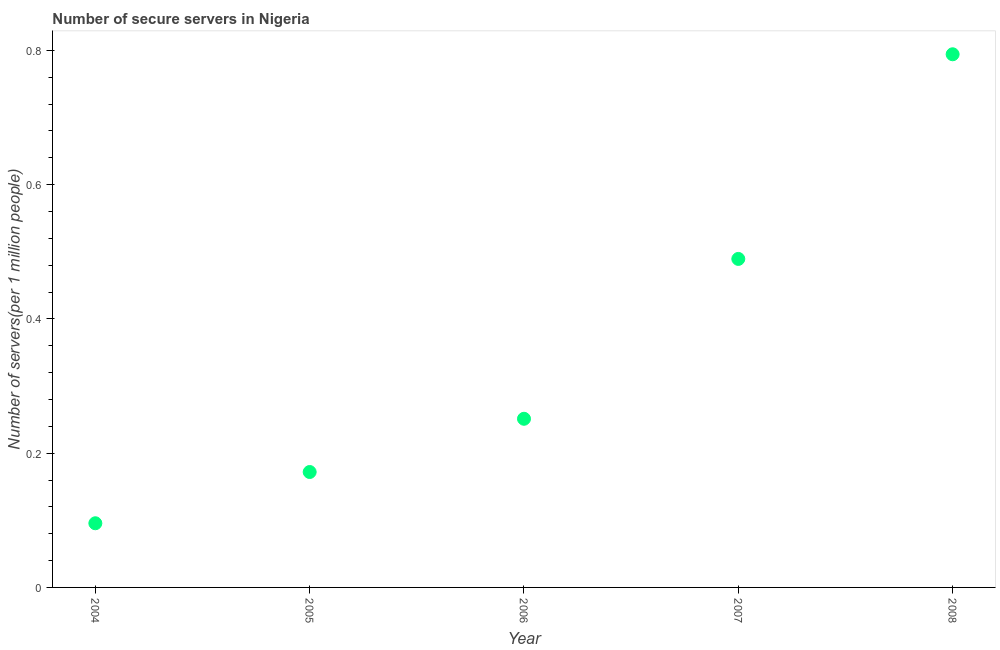What is the number of secure internet servers in 2004?
Provide a succinct answer. 0.1. Across all years, what is the maximum number of secure internet servers?
Keep it short and to the point. 0.79. Across all years, what is the minimum number of secure internet servers?
Offer a very short reply. 0.1. What is the sum of the number of secure internet servers?
Provide a succinct answer. 1.8. What is the difference between the number of secure internet servers in 2005 and 2007?
Offer a terse response. -0.32. What is the average number of secure internet servers per year?
Provide a succinct answer. 0.36. What is the median number of secure internet servers?
Provide a short and direct response. 0.25. In how many years, is the number of secure internet servers greater than 0.68 ?
Your response must be concise. 1. Do a majority of the years between 2006 and 2008 (inclusive) have number of secure internet servers greater than 0.6000000000000001 ?
Offer a terse response. No. What is the ratio of the number of secure internet servers in 2005 to that in 2008?
Provide a succinct answer. 0.22. Is the number of secure internet servers in 2005 less than that in 2007?
Ensure brevity in your answer.  Yes. What is the difference between the highest and the second highest number of secure internet servers?
Provide a short and direct response. 0.3. Is the sum of the number of secure internet servers in 2005 and 2008 greater than the maximum number of secure internet servers across all years?
Your response must be concise. Yes. What is the difference between the highest and the lowest number of secure internet servers?
Make the answer very short. 0.7. In how many years, is the number of secure internet servers greater than the average number of secure internet servers taken over all years?
Your answer should be compact. 2. How many dotlines are there?
Keep it short and to the point. 1. What is the difference between two consecutive major ticks on the Y-axis?
Provide a short and direct response. 0.2. Are the values on the major ticks of Y-axis written in scientific E-notation?
Your response must be concise. No. Does the graph contain any zero values?
Offer a very short reply. No. Does the graph contain grids?
Provide a short and direct response. No. What is the title of the graph?
Keep it short and to the point. Number of secure servers in Nigeria. What is the label or title of the Y-axis?
Make the answer very short. Number of servers(per 1 million people). What is the Number of servers(per 1 million people) in 2004?
Make the answer very short. 0.1. What is the Number of servers(per 1 million people) in 2005?
Offer a very short reply. 0.17. What is the Number of servers(per 1 million people) in 2006?
Provide a succinct answer. 0.25. What is the Number of servers(per 1 million people) in 2007?
Offer a terse response. 0.49. What is the Number of servers(per 1 million people) in 2008?
Offer a very short reply. 0.79. What is the difference between the Number of servers(per 1 million people) in 2004 and 2005?
Make the answer very short. -0.08. What is the difference between the Number of servers(per 1 million people) in 2004 and 2006?
Your answer should be very brief. -0.16. What is the difference between the Number of servers(per 1 million people) in 2004 and 2007?
Give a very brief answer. -0.39. What is the difference between the Number of servers(per 1 million people) in 2004 and 2008?
Provide a short and direct response. -0.7. What is the difference between the Number of servers(per 1 million people) in 2005 and 2006?
Ensure brevity in your answer.  -0.08. What is the difference between the Number of servers(per 1 million people) in 2005 and 2007?
Offer a very short reply. -0.32. What is the difference between the Number of servers(per 1 million people) in 2005 and 2008?
Provide a short and direct response. -0.62. What is the difference between the Number of servers(per 1 million people) in 2006 and 2007?
Make the answer very short. -0.24. What is the difference between the Number of servers(per 1 million people) in 2006 and 2008?
Ensure brevity in your answer.  -0.54. What is the difference between the Number of servers(per 1 million people) in 2007 and 2008?
Offer a terse response. -0.3. What is the ratio of the Number of servers(per 1 million people) in 2004 to that in 2005?
Make the answer very short. 0.56. What is the ratio of the Number of servers(per 1 million people) in 2004 to that in 2006?
Your response must be concise. 0.38. What is the ratio of the Number of servers(per 1 million people) in 2004 to that in 2007?
Offer a very short reply. 0.2. What is the ratio of the Number of servers(per 1 million people) in 2004 to that in 2008?
Keep it short and to the point. 0.12. What is the ratio of the Number of servers(per 1 million people) in 2005 to that in 2006?
Provide a short and direct response. 0.68. What is the ratio of the Number of servers(per 1 million people) in 2005 to that in 2007?
Give a very brief answer. 0.35. What is the ratio of the Number of servers(per 1 million people) in 2005 to that in 2008?
Your answer should be very brief. 0.22. What is the ratio of the Number of servers(per 1 million people) in 2006 to that in 2007?
Offer a terse response. 0.51. What is the ratio of the Number of servers(per 1 million people) in 2006 to that in 2008?
Ensure brevity in your answer.  0.32. What is the ratio of the Number of servers(per 1 million people) in 2007 to that in 2008?
Your response must be concise. 0.62. 